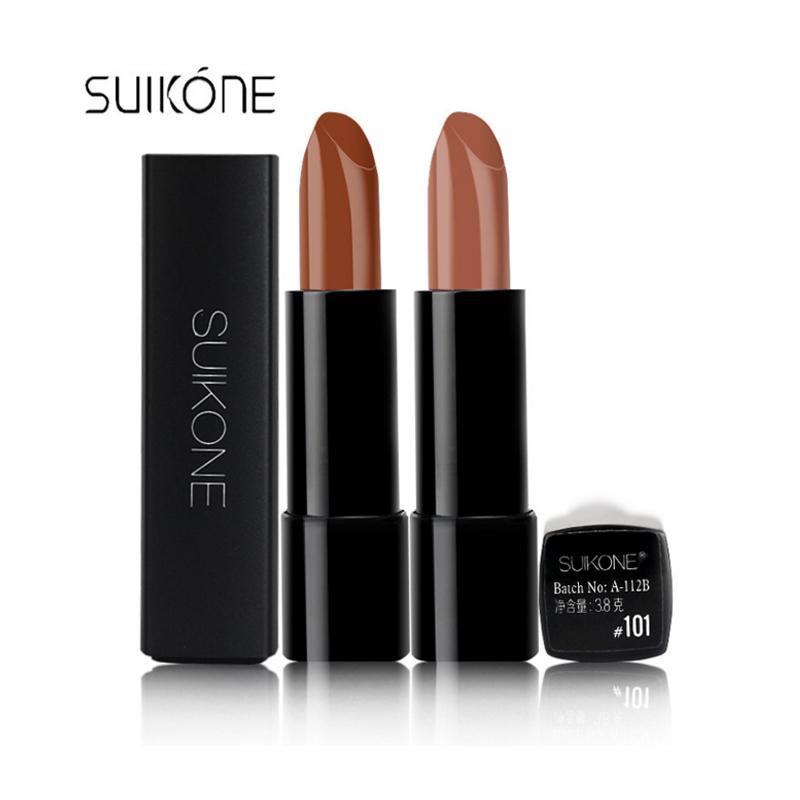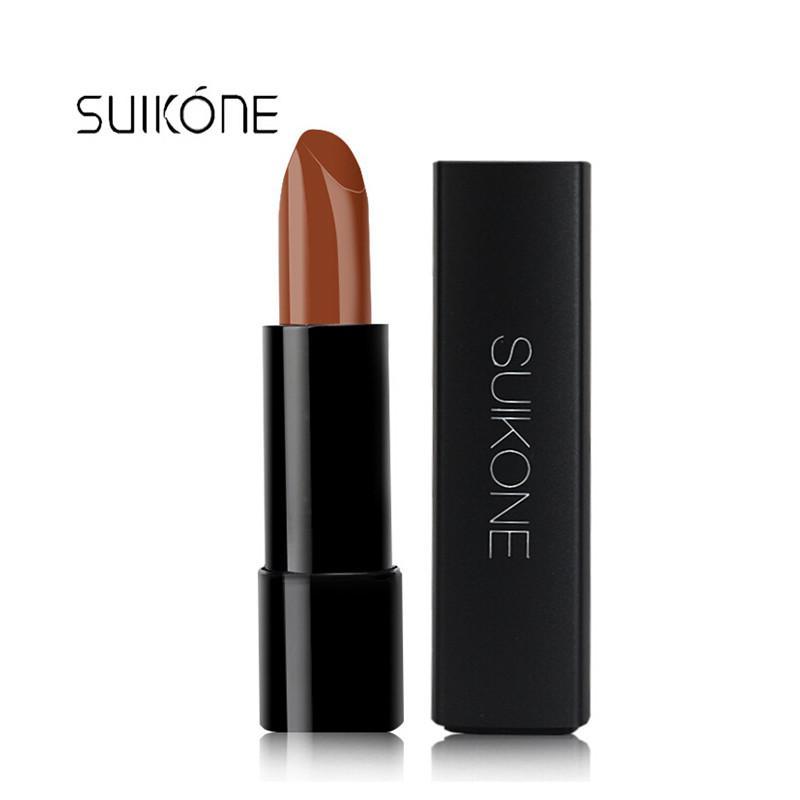The first image is the image on the left, the second image is the image on the right. Considering the images on both sides, is "One image contains exactly two colors of lipstick." valid? Answer yes or no. Yes. 